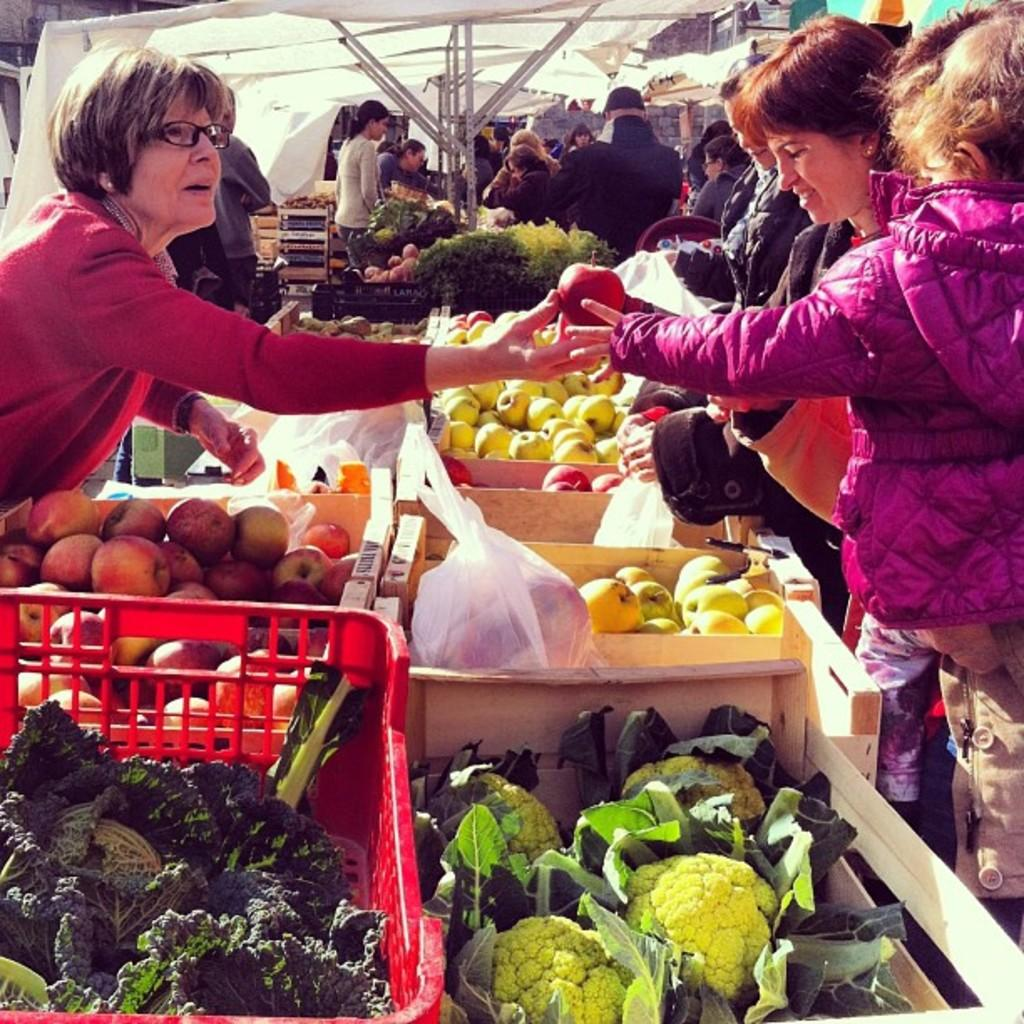What type of location is depicted in the image? There is a market in the image. What are the people on the right side of the image doing? The people on the right side of the image are buying fruits and vegetables. What can be seen on the left side of the image? There are other people on the left side of the image. What type of glassware is being used for dinner in the image? There is no dinner or glassware present in the image; it depicts a market with people buying fruits and vegetables. 